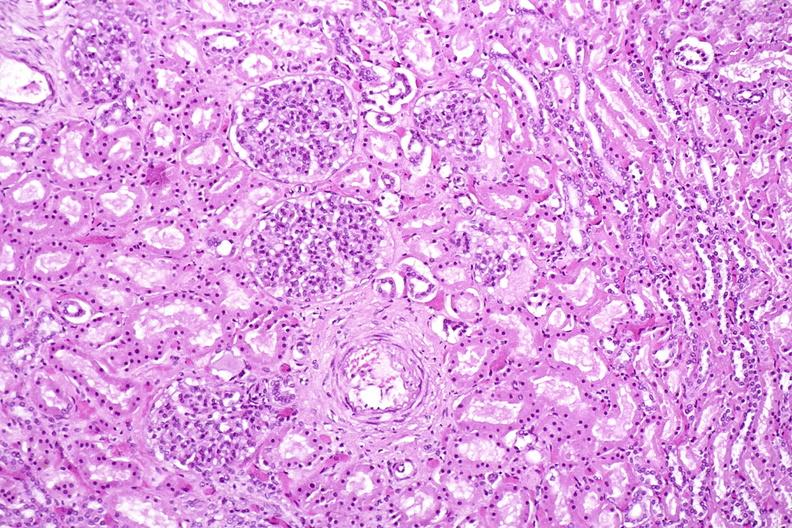where is this?
Answer the question using a single word or phrase. Urinary 